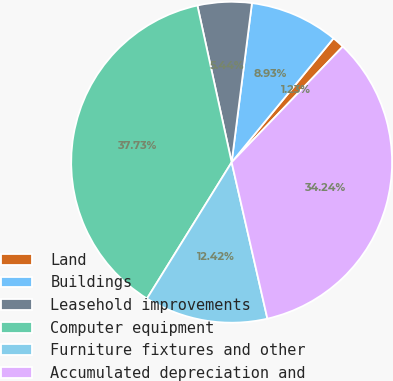<chart> <loc_0><loc_0><loc_500><loc_500><pie_chart><fcel>Land<fcel>Buildings<fcel>Leasehold improvements<fcel>Computer equipment<fcel>Furniture fixtures and other<fcel>Accumulated depreciation and<nl><fcel>1.23%<fcel>8.93%<fcel>5.44%<fcel>37.73%<fcel>12.42%<fcel>34.24%<nl></chart> 